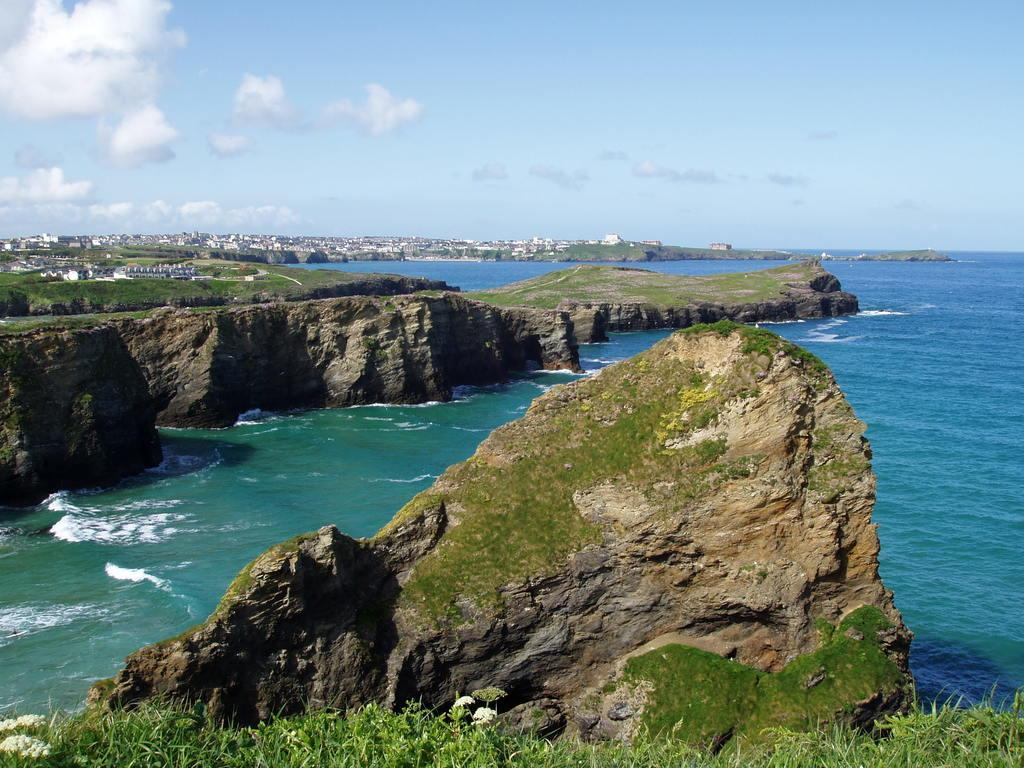What type of geographical feature is present in the image? There is a cliff in the image. What can be seen at the bottom of the cliff? There is grassland at the bottom side of the image. What type of coil is wrapped around the cliff in the image? There is no coil present in the image; it only features a cliff and grassland. What type of shirt is the person wearing while standing on the cliff? There is no person present in the image, so it is impossible to determine what type of shirt they might be wearing. 